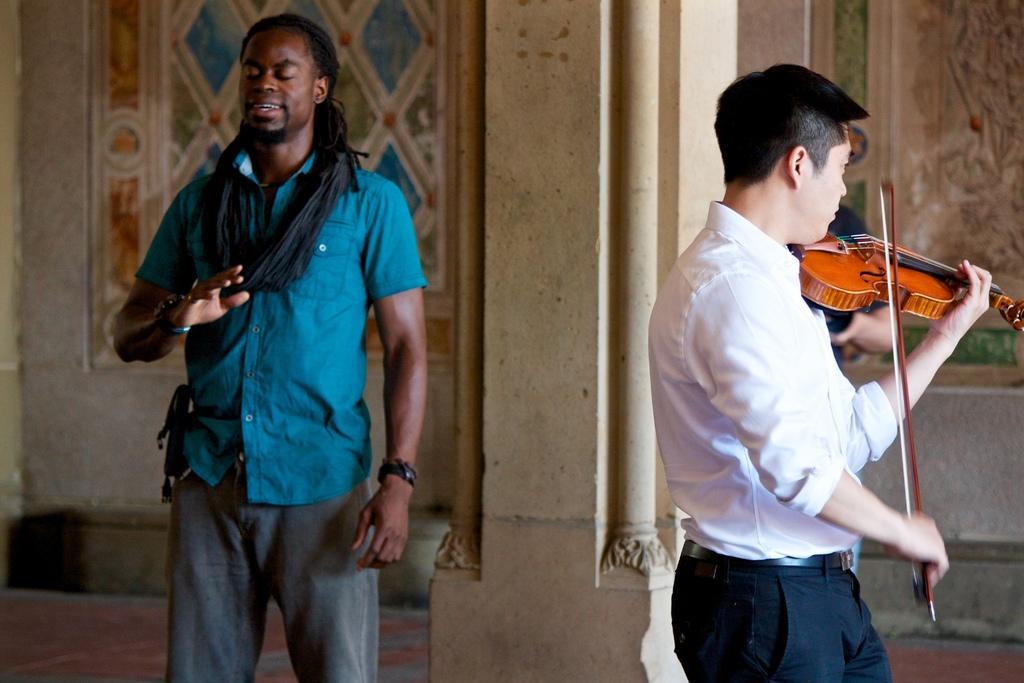How would you summarize this image in a sentence or two? This picture shows a man standing and another man standing and playing violin 